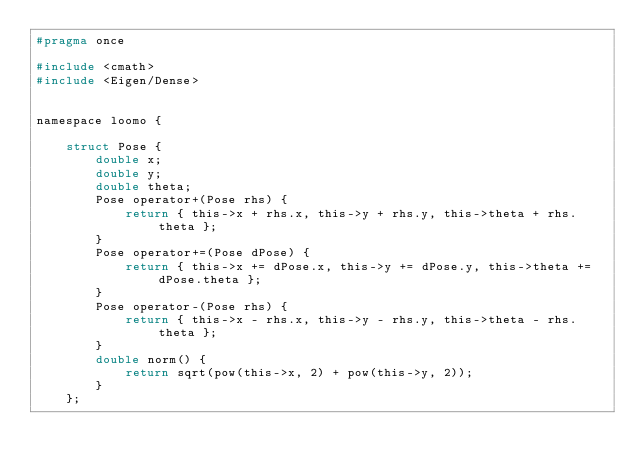<code> <loc_0><loc_0><loc_500><loc_500><_C_>#pragma once

#include <cmath>
#include <Eigen/Dense>


namespace loomo {

    struct Pose {
        double x;
        double y;
        double theta;
        Pose operator+(Pose rhs) {
            return { this->x + rhs.x, this->y + rhs.y, this->theta + rhs.theta };
        }
        Pose operator+=(Pose dPose) {
            return { this->x += dPose.x, this->y += dPose.y, this->theta += dPose.theta };
        }
        Pose operator-(Pose rhs) {
            return { this->x - rhs.x, this->y - rhs.y, this->theta - rhs.theta };
        }
        double norm() {
            return sqrt(pow(this->x, 2) + pow(this->y, 2));
        }
    };
</code> 